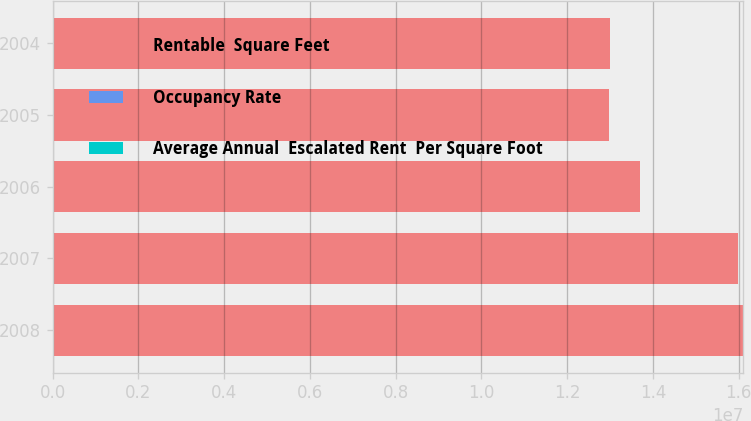Convert chart. <chart><loc_0><loc_0><loc_500><loc_500><stacked_bar_chart><ecel><fcel>2008<fcel>2007<fcel>2006<fcel>2005<fcel>2004<nl><fcel>Rentable  Square Feet<fcel>1.6108e+07<fcel>1.5994e+07<fcel>1.3692e+07<fcel>1.2972e+07<fcel>1.2989e+07<nl><fcel>Occupancy Rate<fcel>96.7<fcel>97.6<fcel>97.5<fcel>96<fcel>95.5<nl><fcel>Average Annual  Escalated Rent  Per Square Foot<fcel>53.08<fcel>49.34<fcel>46.33<fcel>43.67<fcel>42.22<nl></chart> 